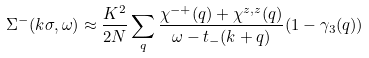<formula> <loc_0><loc_0><loc_500><loc_500>\Sigma ^ { - } ( k \sigma , \omega ) \approx \frac { K ^ { 2 } } { 2 N } \sum _ { q } \frac { \chi ^ { - + } ( q ) + \chi ^ { z , z } ( q ) } { \omega - t _ { - } ( k + q ) } ( 1 - \gamma _ { 3 } ( q ) )</formula> 